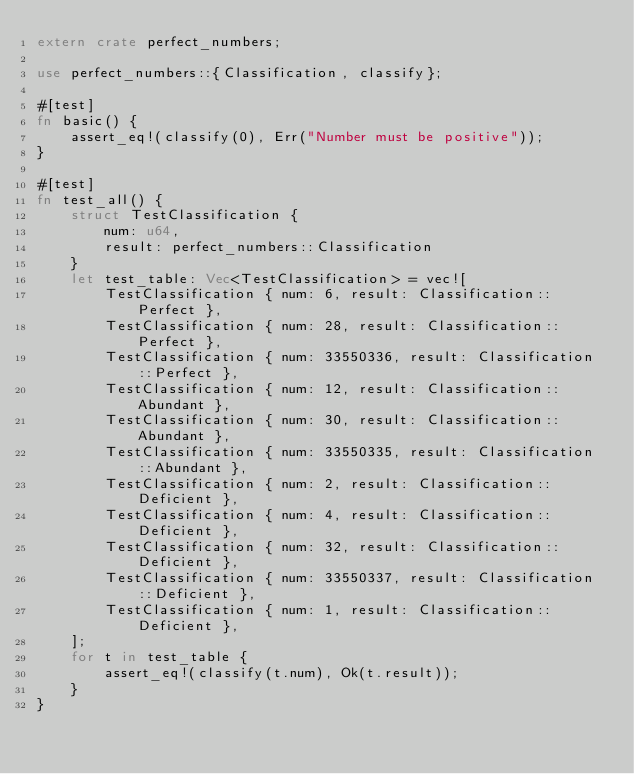<code> <loc_0><loc_0><loc_500><loc_500><_Rust_>extern crate perfect_numbers;

use perfect_numbers::{Classification, classify};

#[test]
fn basic() {
    assert_eq!(classify(0), Err("Number must be positive"));
}

#[test]
fn test_all() {
    struct TestClassification {
        num: u64,
        result: perfect_numbers::Classification
    }
    let test_table: Vec<TestClassification> = vec![
        TestClassification { num: 6, result: Classification::Perfect },
        TestClassification { num: 28, result: Classification::Perfect },
        TestClassification { num: 33550336, result: Classification::Perfect },
        TestClassification { num: 12, result: Classification::Abundant },
        TestClassification { num: 30, result: Classification::Abundant },
        TestClassification { num: 33550335, result: Classification::Abundant },
        TestClassification { num: 2, result: Classification::Deficient },
        TestClassification { num: 4, result: Classification::Deficient },
        TestClassification { num: 32, result: Classification::Deficient },
        TestClassification { num: 33550337, result: Classification::Deficient },
        TestClassification { num: 1, result: Classification::Deficient },
    ];
    for t in test_table {
        assert_eq!(classify(t.num), Ok(t.result));
    }
}
</code> 